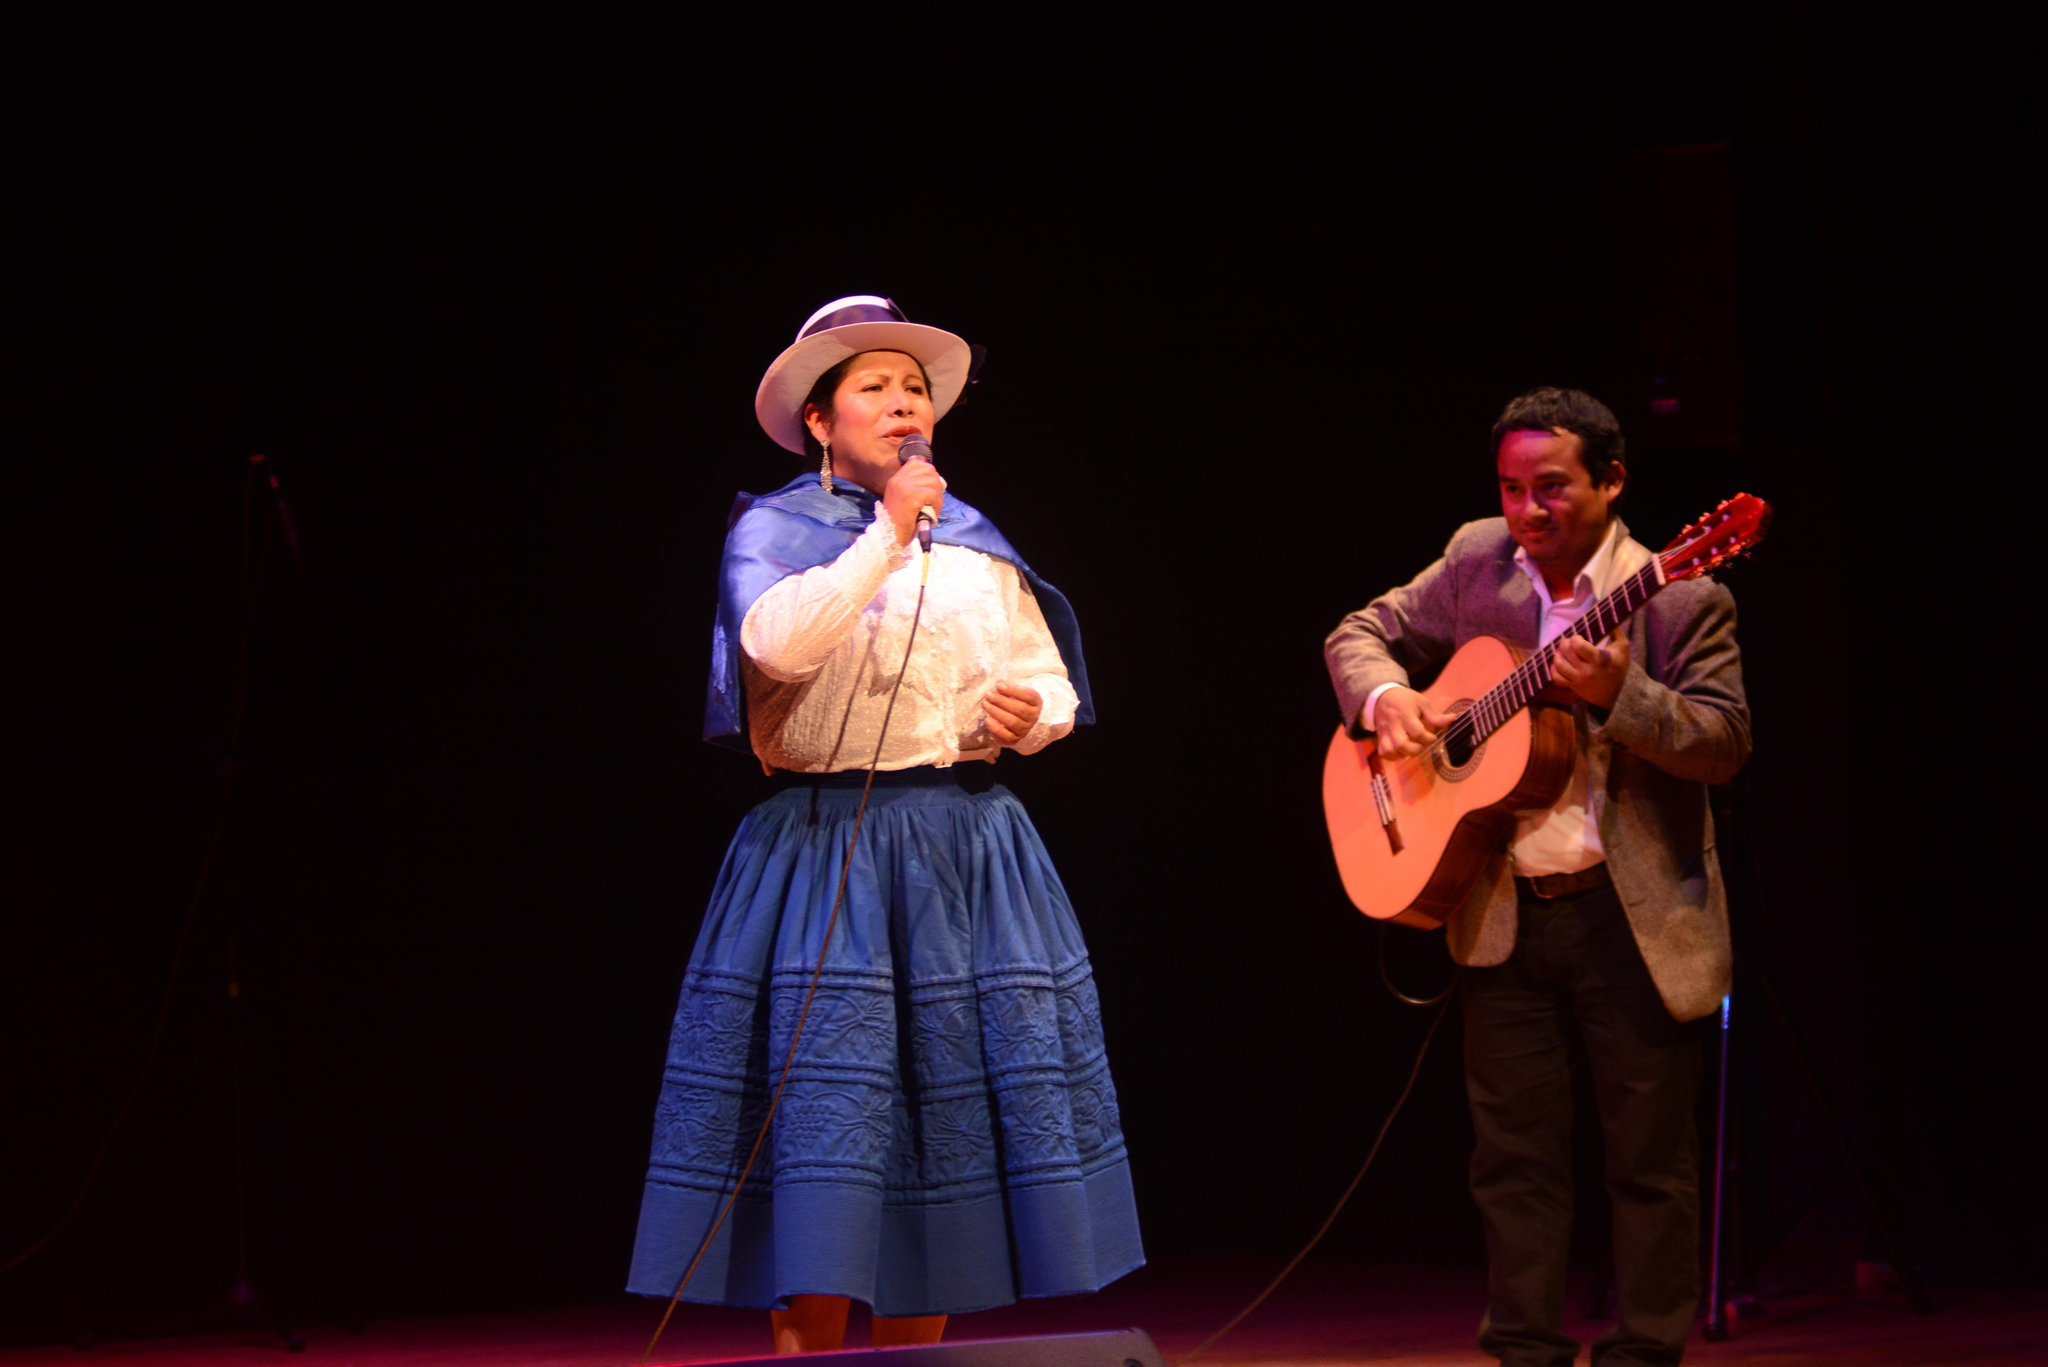What is the woman in the image holding? The woman is holding a microphone. What is the man in the image holding? The man is holding a guitar. Can you describe the interaction between the woman and the man in the image? The woman and the man are likely performing together, as the woman is holding a microphone and the man is holding a guitar. How does the woman stop the rail from moving in the image? There is no rail present in the image, so it is not possible to answer that question. 